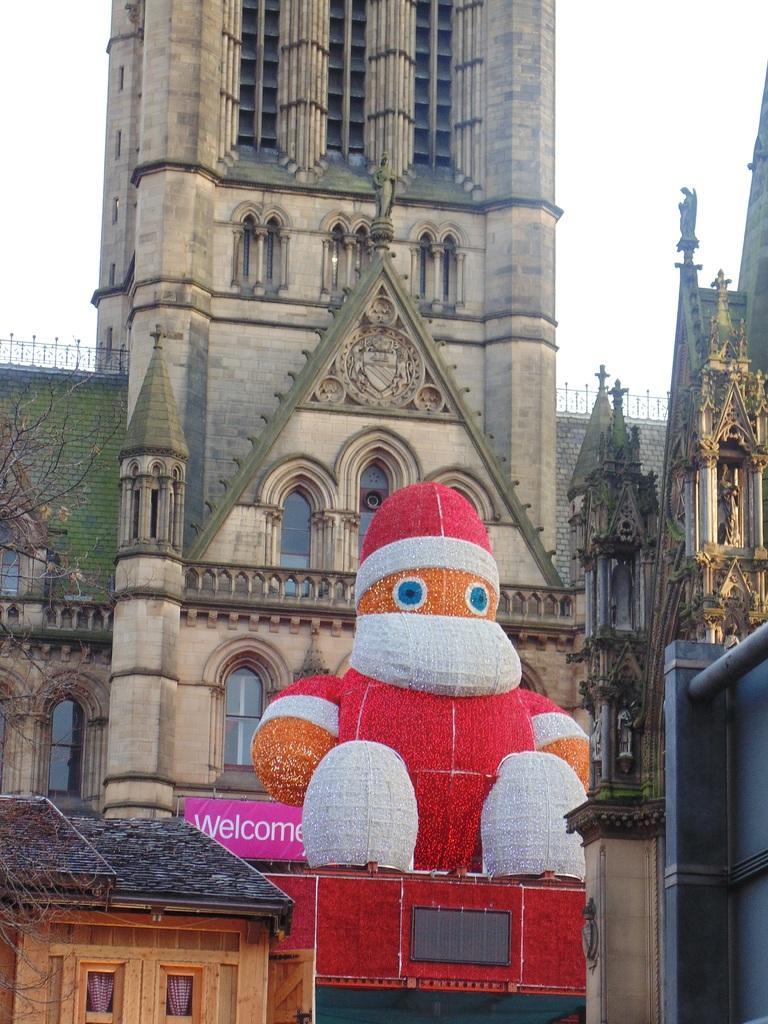Can you describe this image briefly? In this image there is a church, in front of the church there is a Santa Claus, in the background there is a sky. 